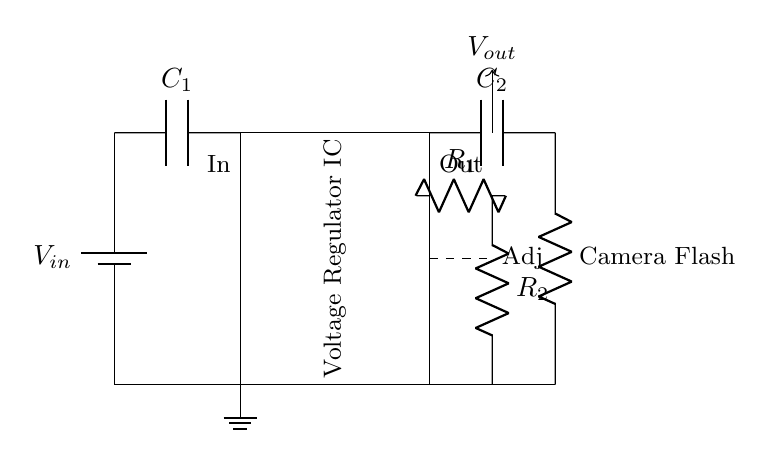What component is used for input filtering? The circuit diagram shows a capacitor labeled C1 connected at the input, which is likely used for filtering to smooth out voltage fluctuations.
Answer: C1 What does the Adj pin control? The Adj pin in the voltage regulator IC is typically used to adjust the output voltage based on feedback from the resistors R1 and R2, regulating the voltage supplied to the load.
Answer: Output voltage How many capacitors are present in the circuit? There are two capacitors in the circuit: one at the input (C1) and one at the output (C2), providing stability and filtering at both ends of the voltage regulator.
Answer: 2 What is the function of the voltage regulator IC? The voltage regulator IC stabilizes the output voltage regardless of variations in input voltage or load conditions, ensuring that the camera flash receives a consistent power supply.
Answer: Stabilization What are R1 and R2 used for? Resistors R1 and R2 form a feedback network that determines the output voltage level by setting the voltage divider ratio, thereby allowing the output voltage to be adjusted as needed.
Answer: Voltage adjustment What is the load represented by in the circuit? The load in the circuit is represented by the resistor labeled as Camera Flash, which indicates it is the component being powered by the regulated voltage from the circuit.
Answer: Camera Flash 